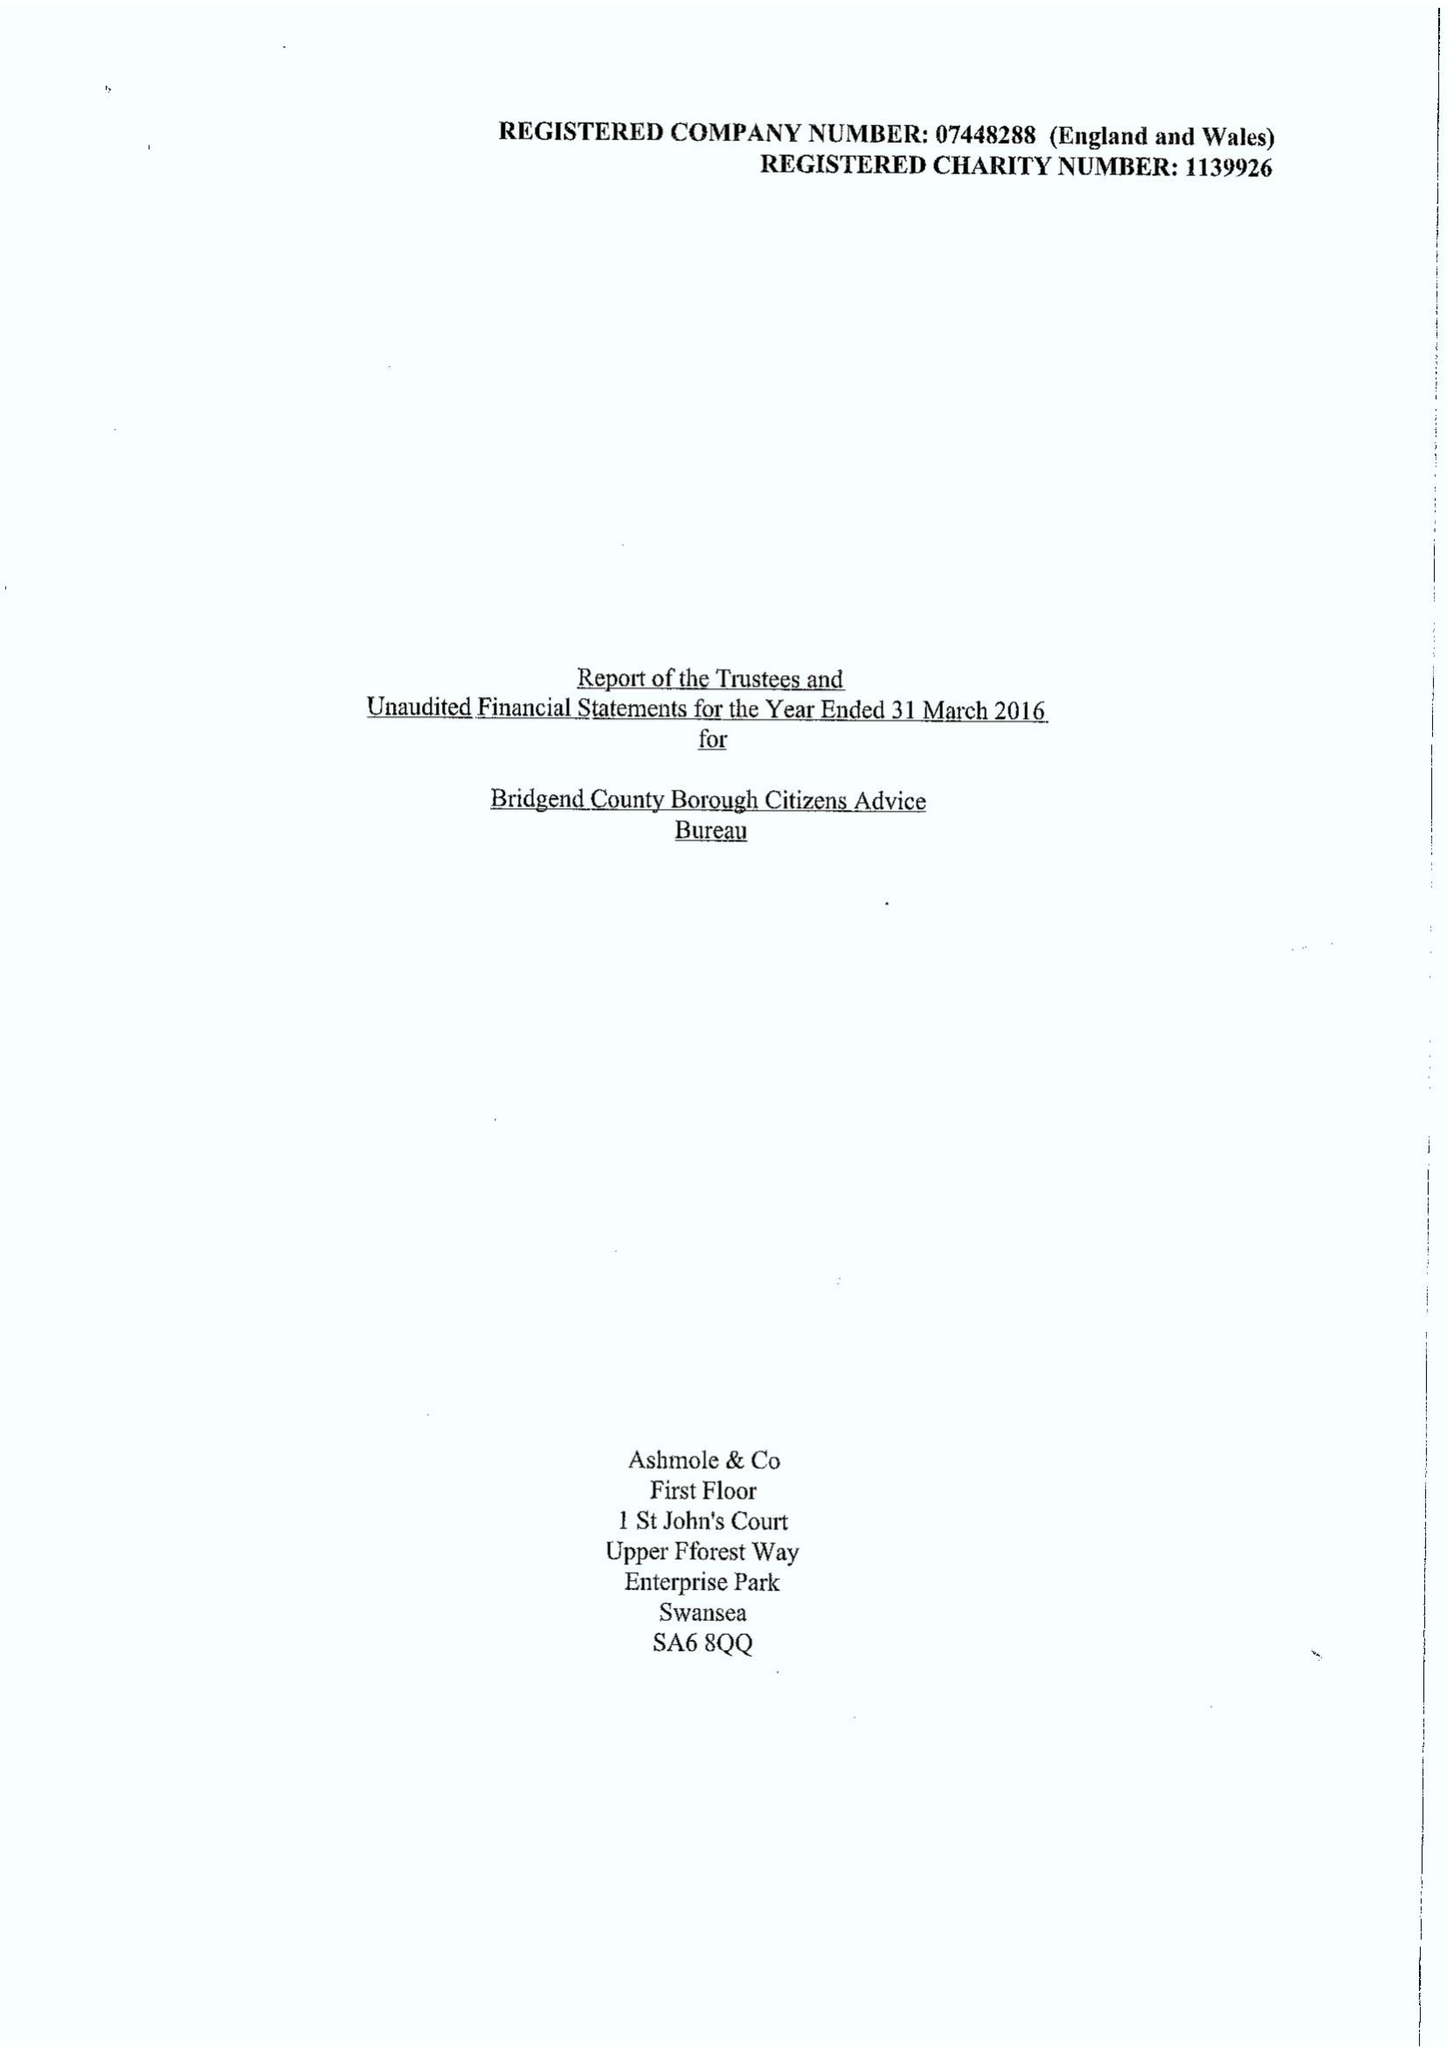What is the value for the address__postcode?
Answer the question using a single word or phrase. CF31 1JD 